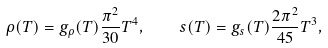Convert formula to latex. <formula><loc_0><loc_0><loc_500><loc_500>\rho ( T ) = g _ { \rho } ( T ) \frac { \pi ^ { 2 } } { 3 0 } T ^ { 4 } , \quad s ( T ) = g _ { s } ( T ) \frac { 2 \pi ^ { 2 } } { 4 5 } T ^ { 3 } ,</formula> 